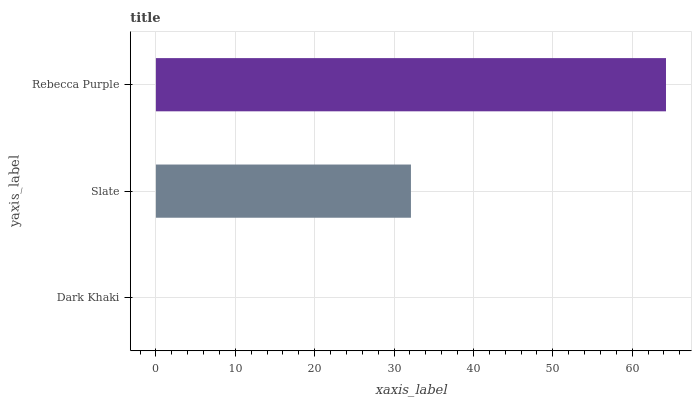Is Dark Khaki the minimum?
Answer yes or no. Yes. Is Rebecca Purple the maximum?
Answer yes or no. Yes. Is Slate the minimum?
Answer yes or no. No. Is Slate the maximum?
Answer yes or no. No. Is Slate greater than Dark Khaki?
Answer yes or no. Yes. Is Dark Khaki less than Slate?
Answer yes or no. Yes. Is Dark Khaki greater than Slate?
Answer yes or no. No. Is Slate less than Dark Khaki?
Answer yes or no. No. Is Slate the high median?
Answer yes or no. Yes. Is Slate the low median?
Answer yes or no. Yes. Is Dark Khaki the high median?
Answer yes or no. No. Is Rebecca Purple the low median?
Answer yes or no. No. 